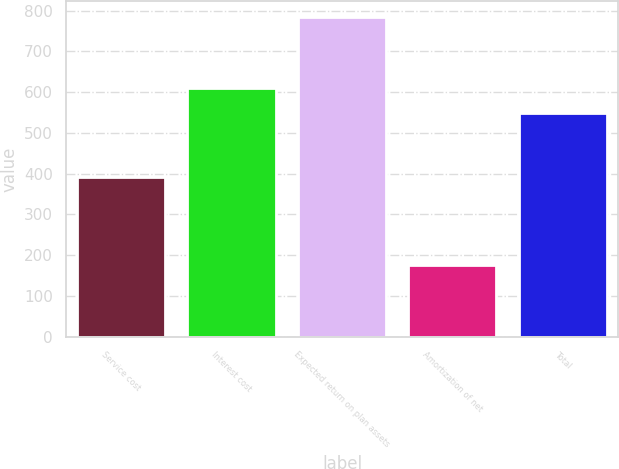<chart> <loc_0><loc_0><loc_500><loc_500><bar_chart><fcel>Service cost<fcel>Interest cost<fcel>Expected return on plan assets<fcel>Amortization of net<fcel>Total<nl><fcel>393<fcel>610.9<fcel>784<fcel>175<fcel>550<nl></chart> 